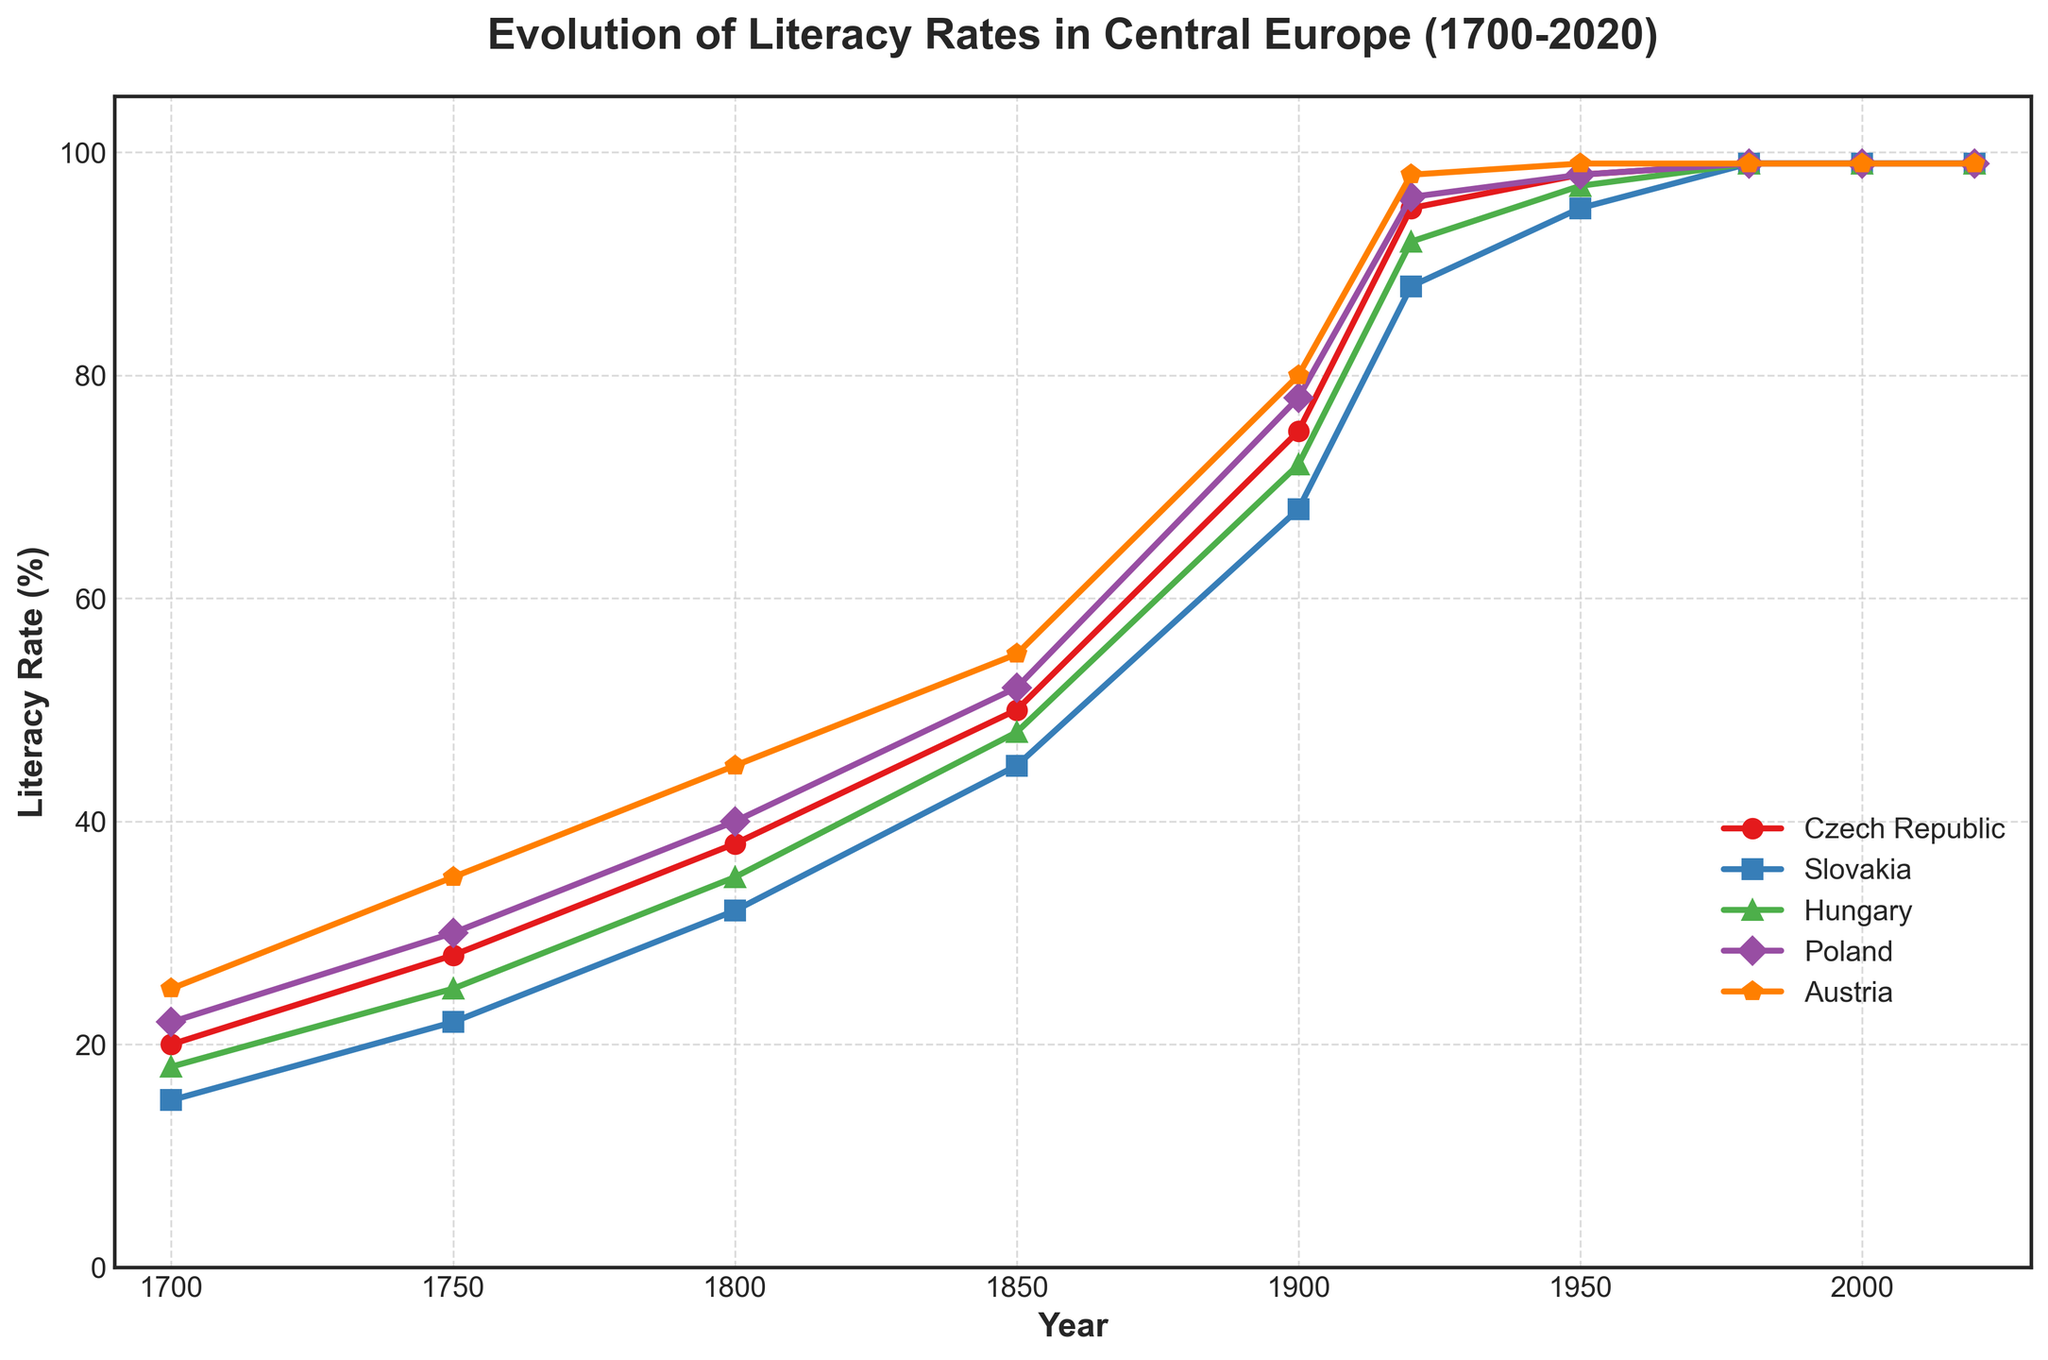What is the literacy rate for Slovakia in the year 1900? Look at the point corresponding to 1900 on the Slovakia line (blue line) in the figure.
Answer: 68 In which year did Poland reach a literacy rate of 95%? Check the point on the Poland line (green line) which reaches a literacy rate of 95%.
Answer: 1920 Which country had the highest literacy rate in 1750? Compare the literacy rates of all countries in the year 1750.
Answer: Austria How did the literacy rates in Hungary and Poland compare in 1980? Observe the points on the Hungary (green) and Poland (purple) lines for the year 1980. Both should have the same literacy rate.
Answer: Equal How much did the literacy rate in the Czech Republic increase between 1700 and 1800? Subtract the literacy rate of 1700 from the literacy rate of 1800 for the Czech Republic. 38 - 20 gives the increase.
Answer: 18 Which country showed the steepest increase in literacy rates between 1850 and 1900? Compare the slopes of the lines between 1850 and 1900 for all countries; the steepest slope indicates the largest increase.
Answer: Slovakia What is the average literacy rate in 1920 for all five countries? Add the literacy rates of all five countries for the year 1920 and divide by 5: (95 + 88 + 92 + 96 + 98) / 5.
Answer: 93.8 How many countries reached a literacy rate of 99% by the year 1980? Check the literacy rates of all the countries for the year 1980 and count those who have reached 99%.
Answer: 5 Which color represents the data for Austria? Identify the color used for the Austria line in the plot legend.
Answer: Orange Did the literacy rate of Hungary ever surpass that of Austria? If so, when? Compare the Hungary (purple) and Austria (orange) lines to find any period where Hungary's literacy rate was higher. It happens before 1920.
Answer: No 